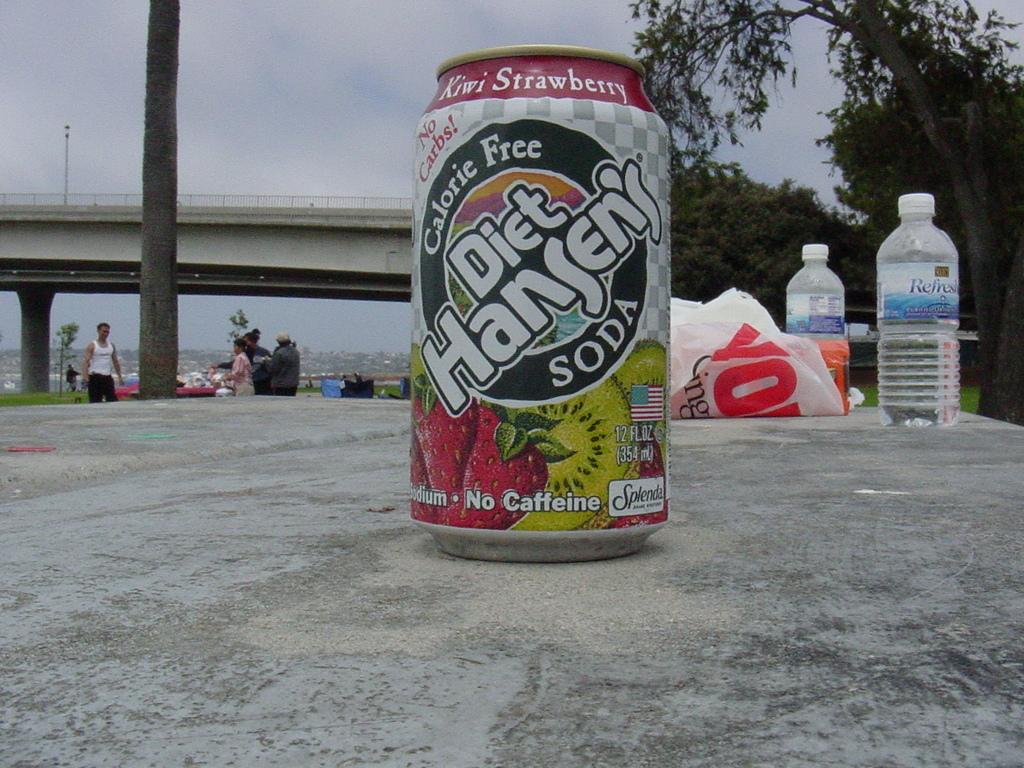How many calories?
Your answer should be compact. 0. 